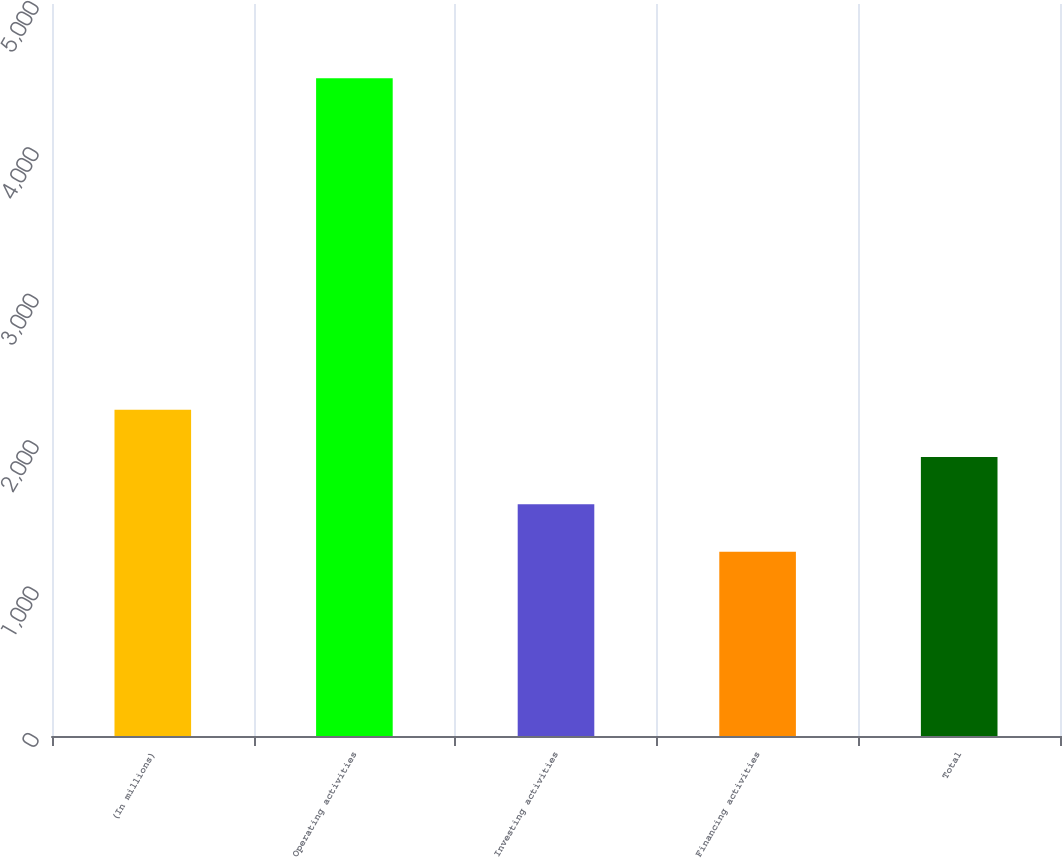Convert chart. <chart><loc_0><loc_0><loc_500><loc_500><bar_chart><fcel>(In millions)<fcel>Operating activities<fcel>Investing activities<fcel>Financing activities<fcel>Total<nl><fcel>2228.9<fcel>4492<fcel>1582.3<fcel>1259<fcel>1905.6<nl></chart> 